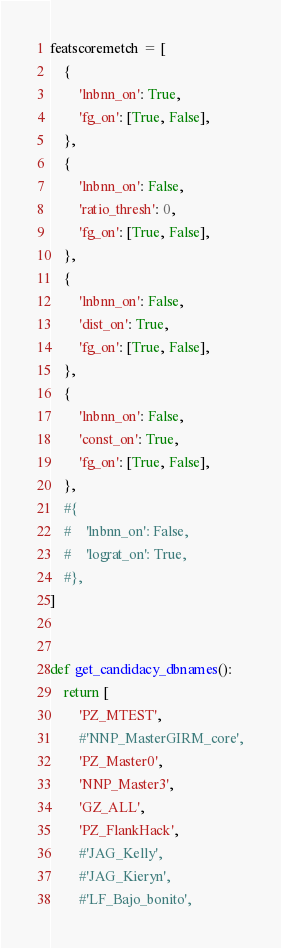Convert code to text. <code><loc_0><loc_0><loc_500><loc_500><_Python_>

featscoremetch = [
    {
        'lnbnn_on': True,
        'fg_on': [True, False],
    },
    {
        'lnbnn_on': False,
        'ratio_thresh': 0,
        'fg_on': [True, False],
    },
    {
        'lnbnn_on': False,
        'dist_on': True,
        'fg_on': [True, False],
    },
    {
        'lnbnn_on': False,
        'const_on': True,
        'fg_on': [True, False],
    },
    #{
    #    'lnbnn_on': False,
    #    'lograt_on': True,
    #},
]


def get_candidacy_dbnames():
    return [
        'PZ_MTEST',
        #'NNP_MasterGIRM_core',
        'PZ_Master0',
        'NNP_Master3',
        'GZ_ALL',
        'PZ_FlankHack',
        #'JAG_Kelly',
        #'JAG_Kieryn',
        #'LF_Bajo_bonito',</code> 